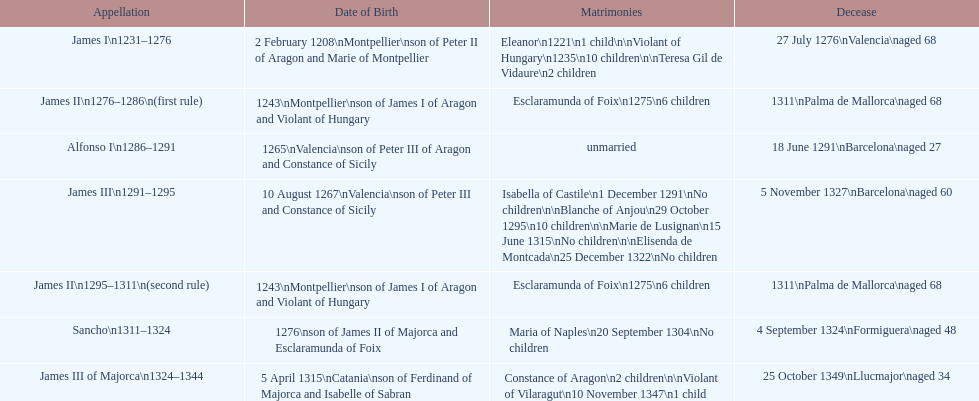How long was james ii in power, including his second rule? 26 years. 